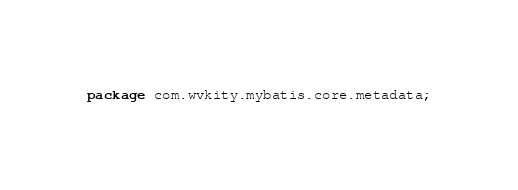Convert code to text. <code><loc_0><loc_0><loc_500><loc_500><_Java_>package com.wvkity.mybatis.core.metadata;</code> 